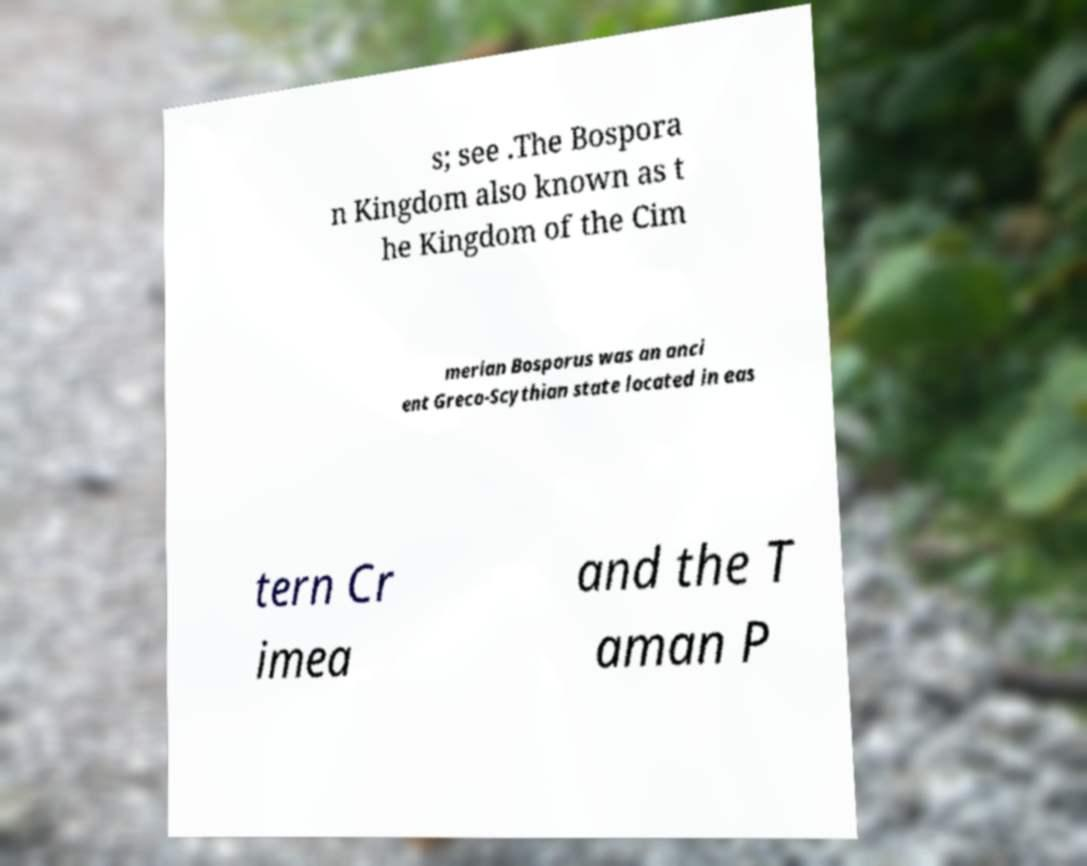For documentation purposes, I need the text within this image transcribed. Could you provide that? s; see .The Bospora n Kingdom also known as t he Kingdom of the Cim merian Bosporus was an anci ent Greco-Scythian state located in eas tern Cr imea and the T aman P 